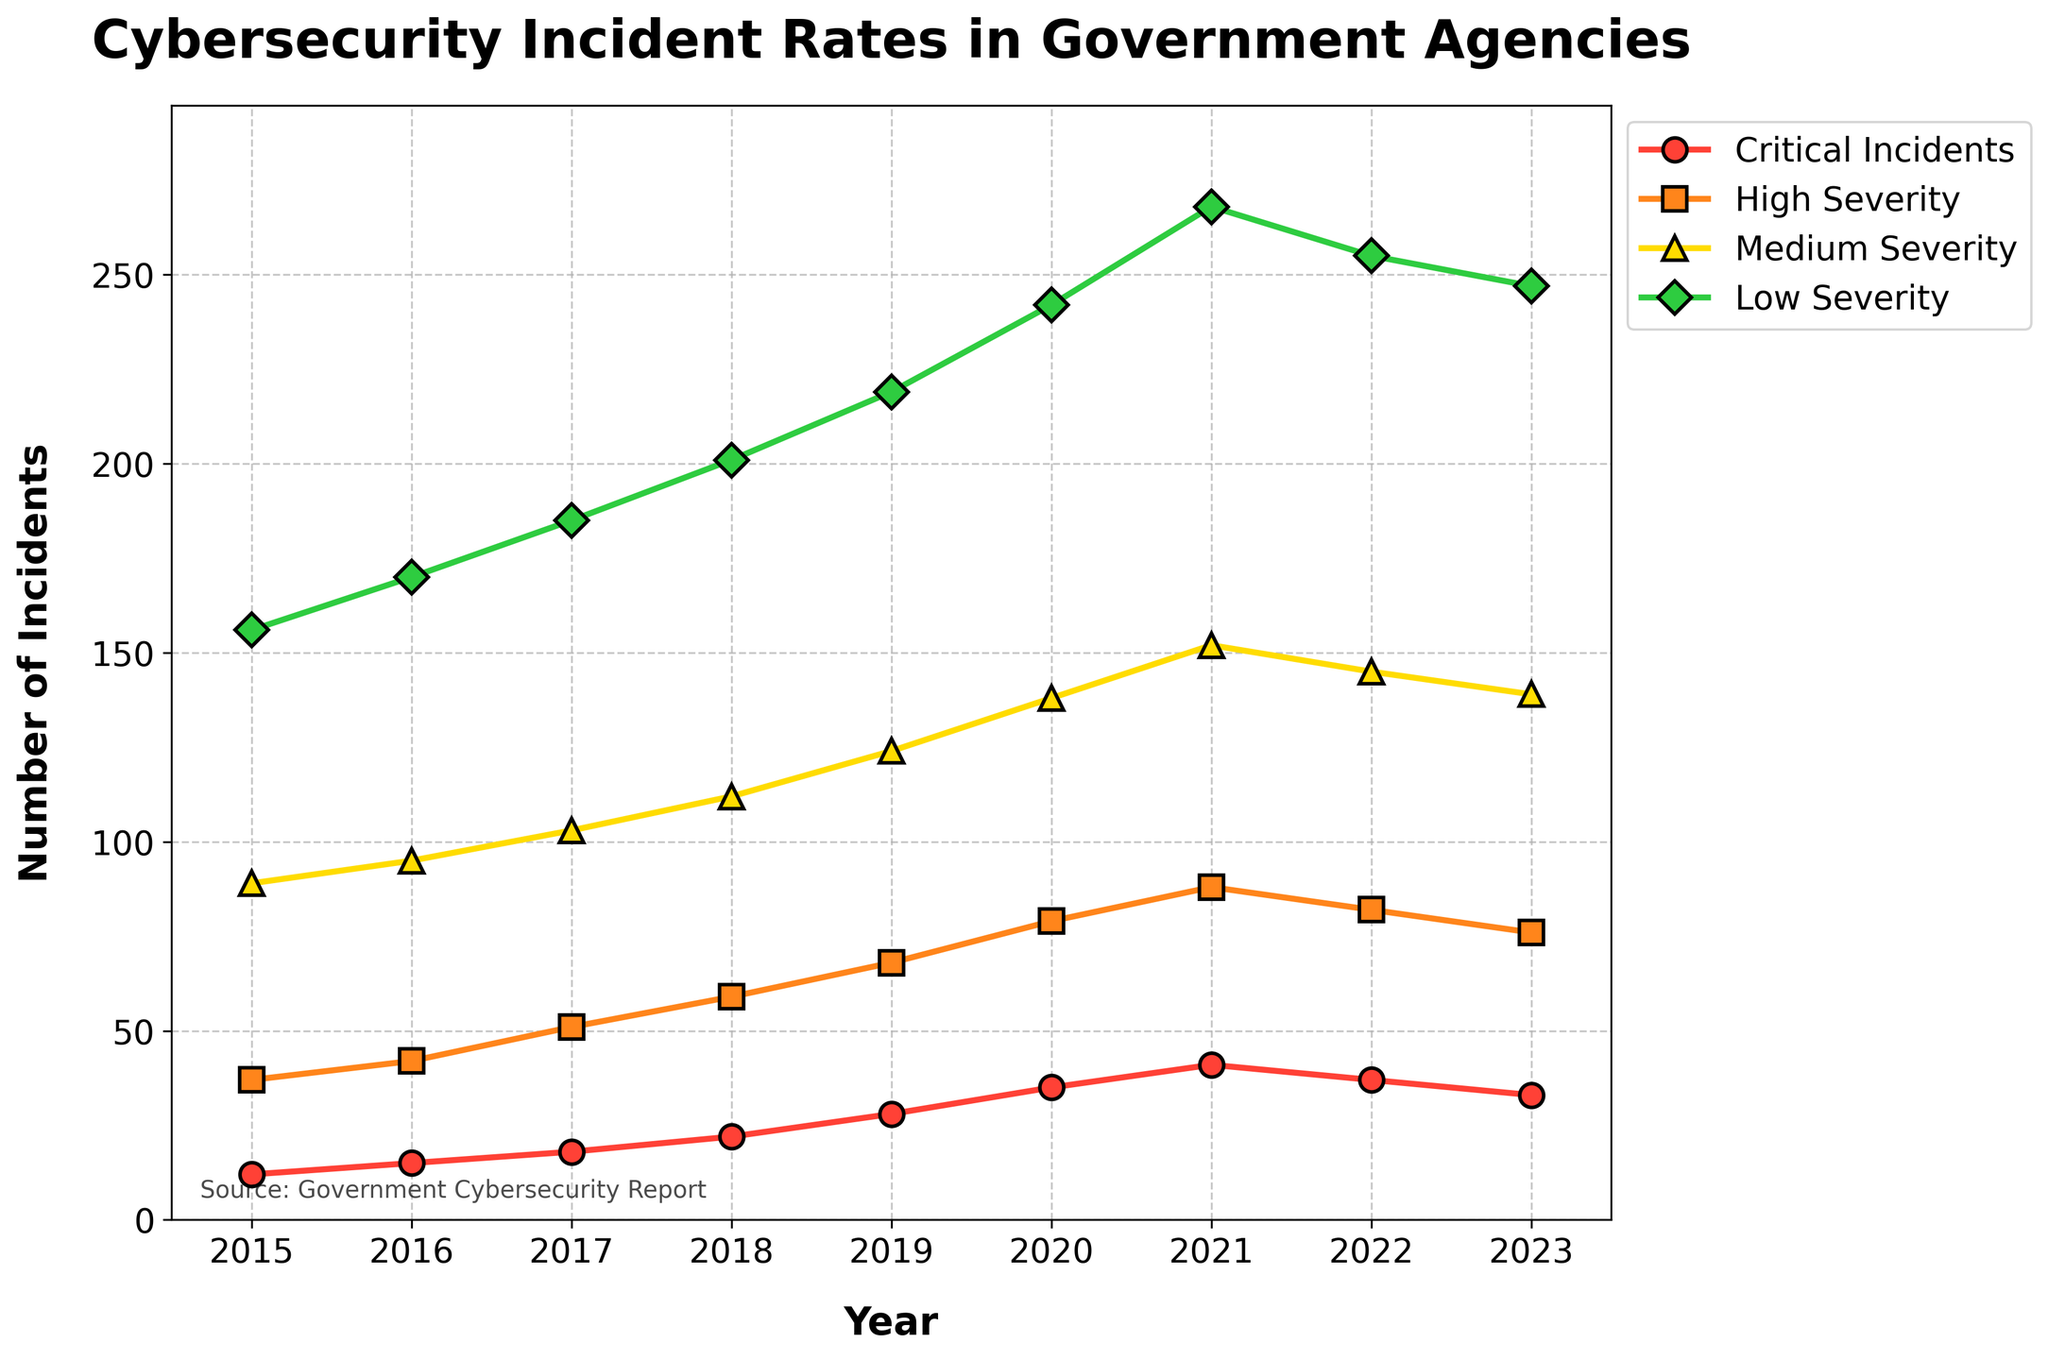What is the trend for Critical Incidents from 2015 to 2023? Look at the line representing Critical Incidents from 2015 to 2023. The general trend is upward until 2021, followed by a decrease in 2022 and 2023.
Answer: Increasing until 2021, then decreasing Which category had the highest number of incidents in 2020? By examining the height of the lines, the Low Severity category had the highest number of incidents in 2020.
Answer: Low Severity In which year did High Severity incidents peak? Identify the highest point in the High Severity line. The peak occurs in 2021.
Answer: 2021 How many total Critical Incidents occurred between 2015 and 2023? Add the values of Critical Incidents from 2015 to 2023: 12 + 15 + 18 + 22 + 28 + 35 + 41 + 37 + 33 = 241.
Answer: 241 What is the average number of Medium Severity incidents over the period? Sum the values of Medium Severity incidents and then divide by the number of years: (89 + 95 + 103 + 112 + 124 + 138 + 152 + 145 + 139) / 9 = 1,097 / 9.
Answer: 122 In 2018, what was the combined number of Medium and Low Severity incidents? Add the values for Medium and Low Severity incidents in 2018: 112 (Medium) + 201 (Low) = 313.
Answer: 313 Which year saw the biggest drop in Critical Incidents compared to the previous year? Compare the drop between consecutive years. The biggest drop is from 2021 (41) to 2022 (37), a decrease of 4 incidents.
Answer: 2022 What is the difference between High Severity and Low Severity incidents in 2023? Subtract the number of High Severity incidents from the number of Low Severity incidents in 2023: 247 (Low) - 76 (High) = 171.
Answer: 171 Which category showed the most consistent increase each year until 2021? The line for Medium Severity consistently increases each year from 2015 to 2021 without any decreases.
Answer: Medium Severity 